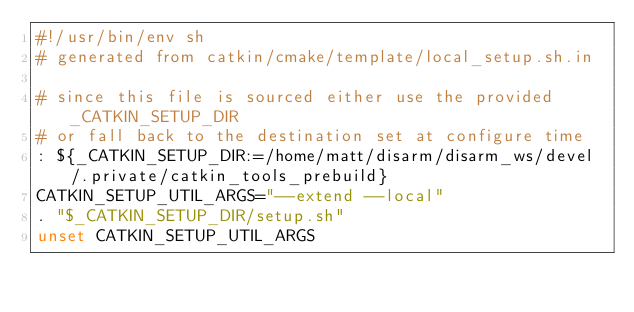<code> <loc_0><loc_0><loc_500><loc_500><_Bash_>#!/usr/bin/env sh
# generated from catkin/cmake/template/local_setup.sh.in

# since this file is sourced either use the provided _CATKIN_SETUP_DIR
# or fall back to the destination set at configure time
: ${_CATKIN_SETUP_DIR:=/home/matt/disarm/disarm_ws/devel/.private/catkin_tools_prebuild}
CATKIN_SETUP_UTIL_ARGS="--extend --local"
. "$_CATKIN_SETUP_DIR/setup.sh"
unset CATKIN_SETUP_UTIL_ARGS
</code> 